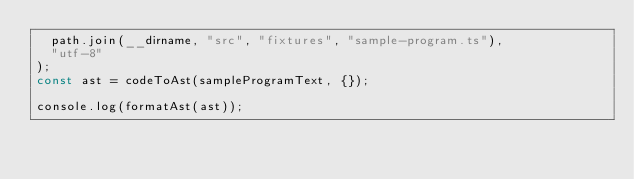Convert code to text. <code><loc_0><loc_0><loc_500><loc_500><_JavaScript_>  path.join(__dirname, "src", "fixtures", "sample-program.ts"),
  "utf-8"
);
const ast = codeToAst(sampleProgramText, {});

console.log(formatAst(ast));
</code> 